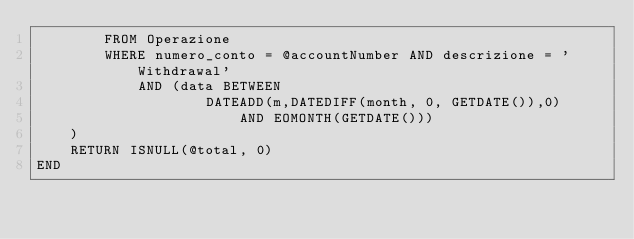<code> <loc_0><loc_0><loc_500><loc_500><_SQL_>		FROM Operazione
		WHERE numero_conto = @accountNumber AND descrizione = 'Withdrawal'
			AND (data BETWEEN 
					DATEADD(m,DATEDIFF(month, 0, GETDATE()),0)
						AND EOMONTH(GETDATE()))
	)
	RETURN ISNULL(@total, 0)
END</code> 